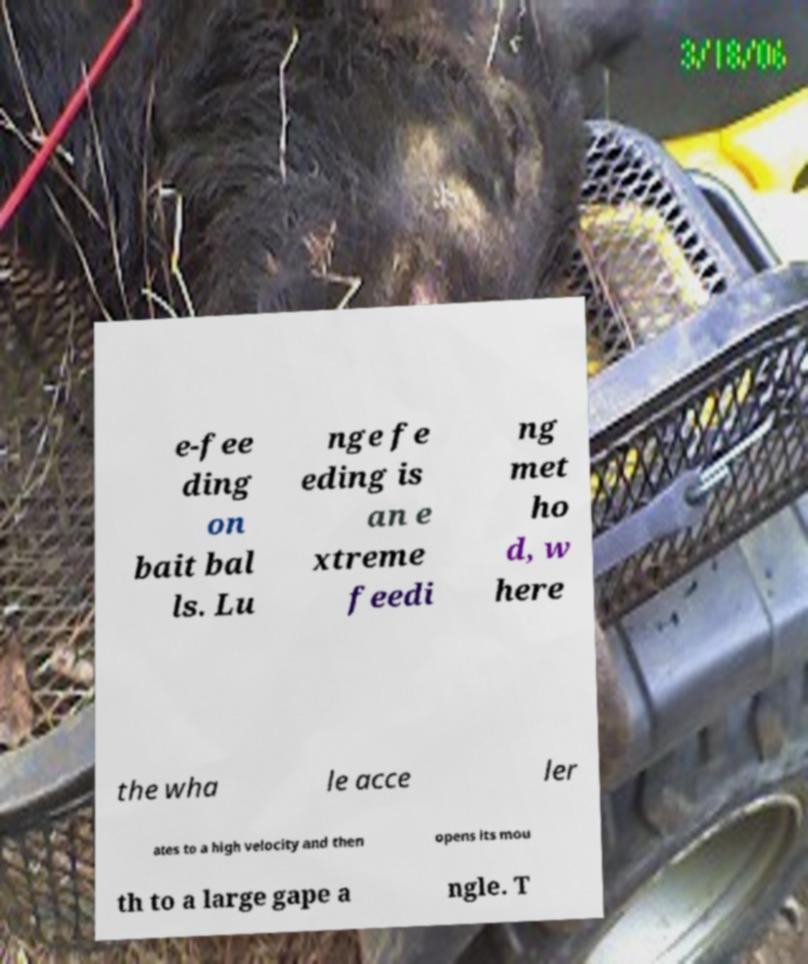Could you extract and type out the text from this image? e-fee ding on bait bal ls. Lu nge fe eding is an e xtreme feedi ng met ho d, w here the wha le acce ler ates to a high velocity and then opens its mou th to a large gape a ngle. T 